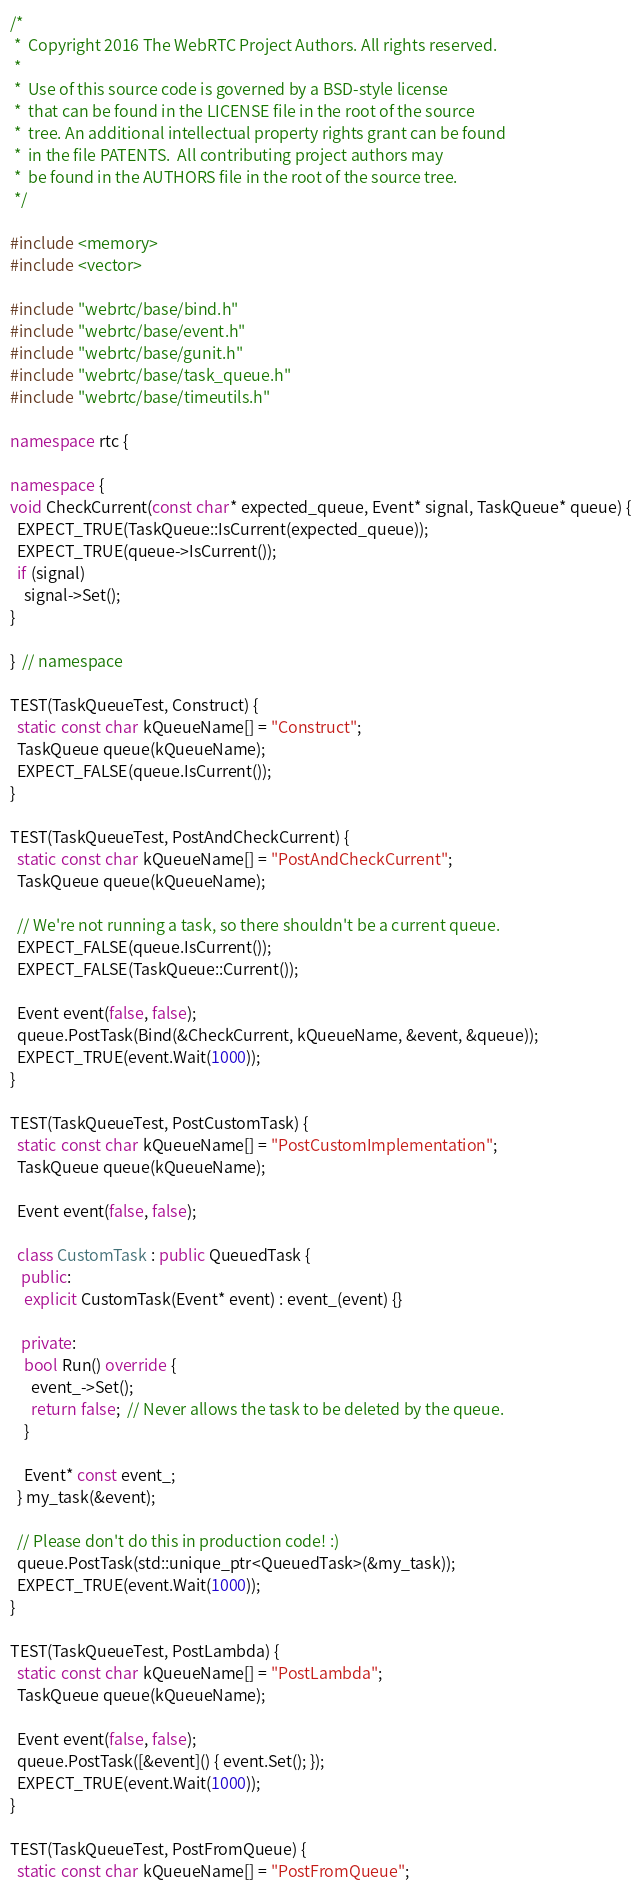<code> <loc_0><loc_0><loc_500><loc_500><_C++_>/*
 *  Copyright 2016 The WebRTC Project Authors. All rights reserved.
 *
 *  Use of this source code is governed by a BSD-style license
 *  that can be found in the LICENSE file in the root of the source
 *  tree. An additional intellectual property rights grant can be found
 *  in the file PATENTS.  All contributing project authors may
 *  be found in the AUTHORS file in the root of the source tree.
 */

#include <memory>
#include <vector>

#include "webrtc/base/bind.h"
#include "webrtc/base/event.h"
#include "webrtc/base/gunit.h"
#include "webrtc/base/task_queue.h"
#include "webrtc/base/timeutils.h"

namespace rtc {

namespace {
void CheckCurrent(const char* expected_queue, Event* signal, TaskQueue* queue) {
  EXPECT_TRUE(TaskQueue::IsCurrent(expected_queue));
  EXPECT_TRUE(queue->IsCurrent());
  if (signal)
    signal->Set();
}

}  // namespace

TEST(TaskQueueTest, Construct) {
  static const char kQueueName[] = "Construct";
  TaskQueue queue(kQueueName);
  EXPECT_FALSE(queue.IsCurrent());
}

TEST(TaskQueueTest, PostAndCheckCurrent) {
  static const char kQueueName[] = "PostAndCheckCurrent";
  TaskQueue queue(kQueueName);

  // We're not running a task, so there shouldn't be a current queue.
  EXPECT_FALSE(queue.IsCurrent());
  EXPECT_FALSE(TaskQueue::Current());

  Event event(false, false);
  queue.PostTask(Bind(&CheckCurrent, kQueueName, &event, &queue));
  EXPECT_TRUE(event.Wait(1000));
}

TEST(TaskQueueTest, PostCustomTask) {
  static const char kQueueName[] = "PostCustomImplementation";
  TaskQueue queue(kQueueName);

  Event event(false, false);

  class CustomTask : public QueuedTask {
   public:
    explicit CustomTask(Event* event) : event_(event) {}

   private:
    bool Run() override {
      event_->Set();
      return false;  // Never allows the task to be deleted by the queue.
    }

    Event* const event_;
  } my_task(&event);

  // Please don't do this in production code! :)
  queue.PostTask(std::unique_ptr<QueuedTask>(&my_task));
  EXPECT_TRUE(event.Wait(1000));
}

TEST(TaskQueueTest, PostLambda) {
  static const char kQueueName[] = "PostLambda";
  TaskQueue queue(kQueueName);

  Event event(false, false);
  queue.PostTask([&event]() { event.Set(); });
  EXPECT_TRUE(event.Wait(1000));
}

TEST(TaskQueueTest, PostFromQueue) {
  static const char kQueueName[] = "PostFromQueue";</code> 